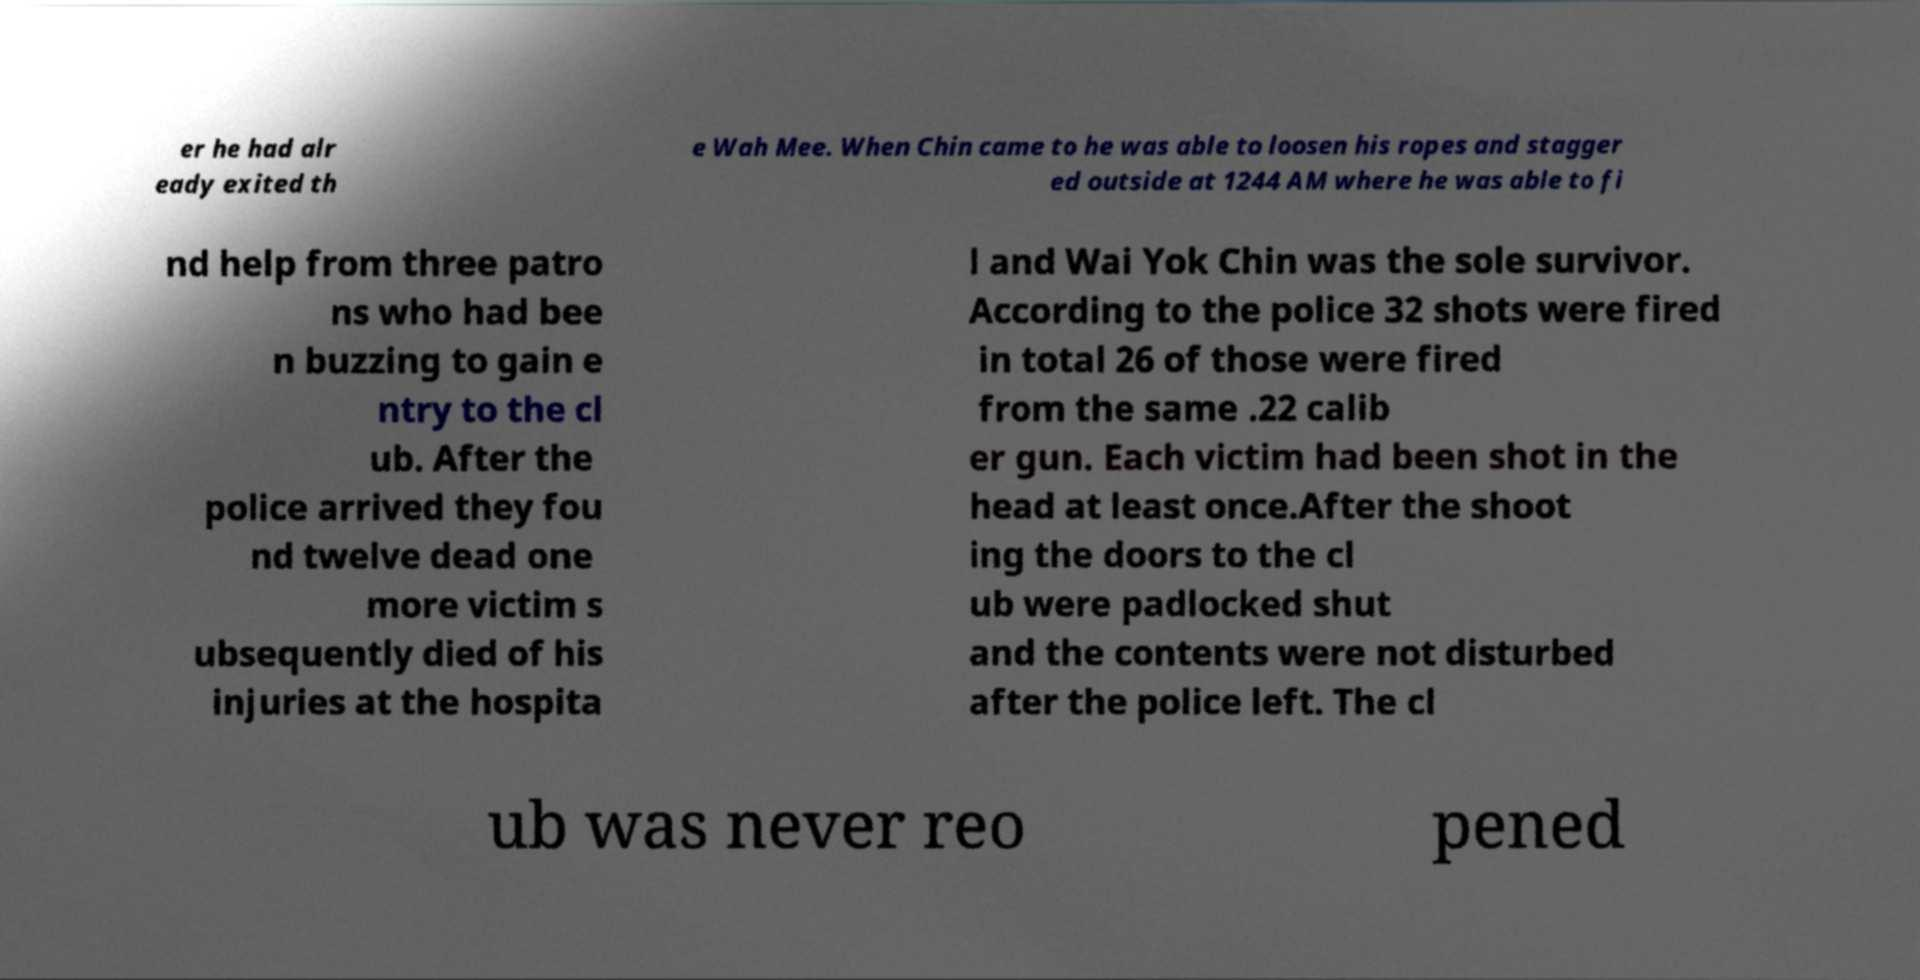Can you read and provide the text displayed in the image?This photo seems to have some interesting text. Can you extract and type it out for me? er he had alr eady exited th e Wah Mee. When Chin came to he was able to loosen his ropes and stagger ed outside at 1244 AM where he was able to fi nd help from three patro ns who had bee n buzzing to gain e ntry to the cl ub. After the police arrived they fou nd twelve dead one more victim s ubsequently died of his injuries at the hospita l and Wai Yok Chin was the sole survivor. According to the police 32 shots were fired in total 26 of those were fired from the same .22 calib er gun. Each victim had been shot in the head at least once.After the shoot ing the doors to the cl ub were padlocked shut and the contents were not disturbed after the police left. The cl ub was never reo pened 